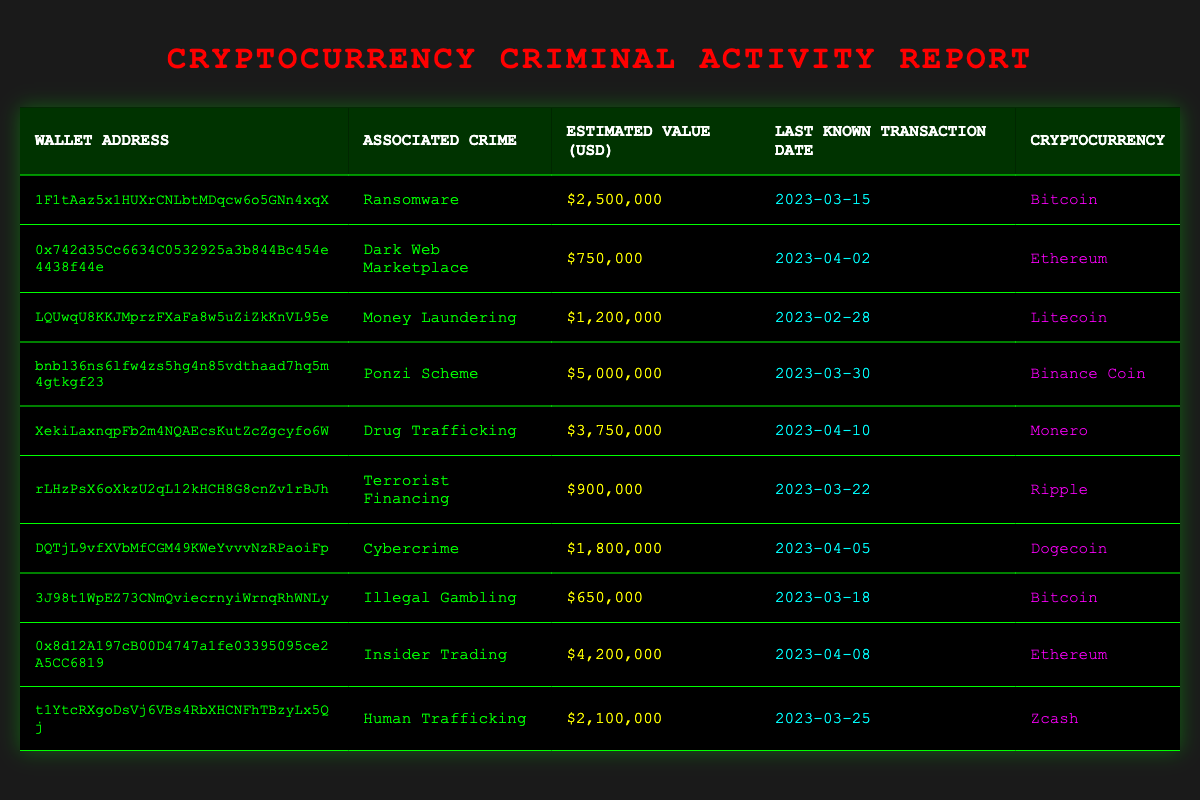What is the total estimated value of the wallets associated with drug trafficking? From the table, there is one wallet associated with drug trafficking. The estimated value for that wallet is $3,750,000. Therefore, the total estimated value is simply this amount.
Answer: 3,750,000 Which cryptocurrency has the highest estimated value associated with crime? By examining the estimated values in the "Estimated Value (USD)" column, the wallet for the Ponzi Scheme associated with Binance Coin has the highest value at $5,000,000.
Answer: Binance Coin How many unique types of crimes are associated with the wallets listed? The crimes listed are Ransomware, Dark Web Marketplace, Money Laundering, Ponzi Scheme, Drug Trafficking, Terrorist Financing, Cybercrime, Illegal Gambling, Insider Trading, and Human Trafficking. Counting these gives a total of 10 unique crime types.
Answer: 10 Is there any wallet address associated with illegal gambling? Looking through the table, the wallet address "3J98t1WpEZ73CNmQviecrnyiWrnqRhWNLy" is associated with illegal gambling. So, the answer is yes.
Answer: Yes What is the average estimated value of all wallet addresses related to cybercrime activity? The only wallet linked to cybercrime has an estimated value of $1,800,000. Thus, the average is simply this value, as there's only one entry.
Answer: 1,800,000 Which crime has the most recent transaction date? The most recent transaction date in the table is "2023-04-10", which is linked to the wallet for drug trafficking. This makes drug trafficking the crime with the most recent transaction.
Answer: Drug Trafficking Are there any wallets linked to Ponzi schemes that have an estimated value over 4 million? The wallet address linked to a Ponzi scheme shows an estimated value of $5,000,000, which is over 4 million. Therefore, the answer is yes.
Answer: Yes What percentage of the total estimated values represented in the table is attributed to ransomware? The total estimated value of all wallets is $2,500,000 (ransomware) + $750,000 + $1,200,000 + $5,000,000 + $3,750,000 + $900,000 + $1,800,000 + $650,000 + $4,200,000 + $2,100,000 = $22,850,000. The percentage attributed to ransomware is ($2,500,000 / $22,850,000) * 100, resulting in approximately 10.95%.
Answer: 10.95% Which crime is associated with the oldest last known transaction date? By checking the "Last Known Transaction Date" column, the earliest date is "2023-02-28", which is associated with money laundering. Hence, money laundering is the crime related to the oldest transaction date.
Answer: Money Laundering 